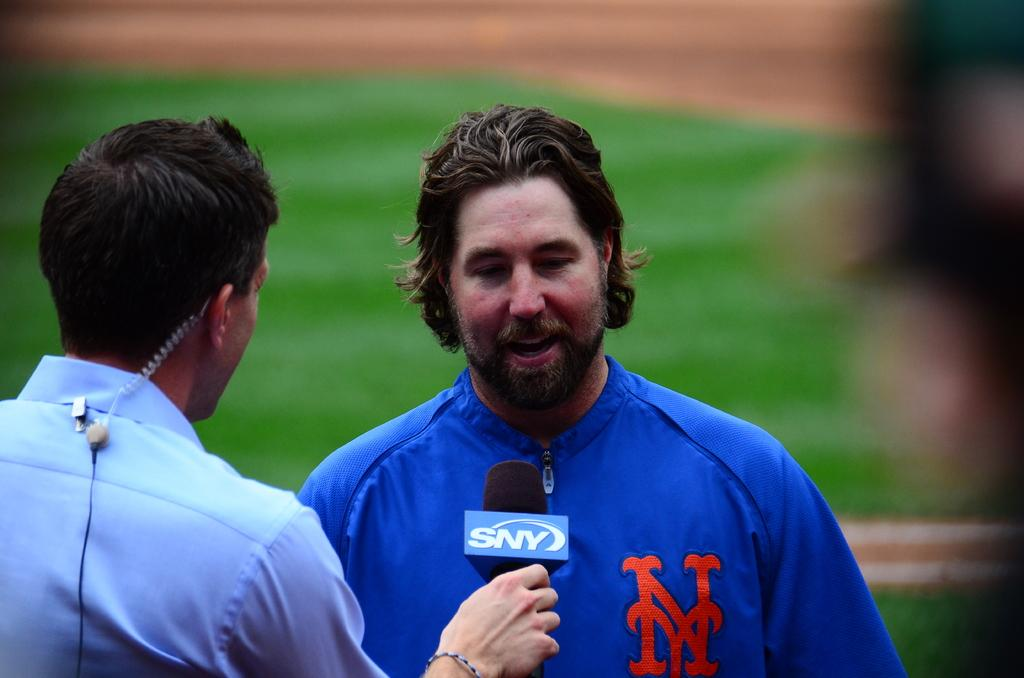<image>
Offer a succinct explanation of the picture presented. A man with NY on his shirt is being interviewed. 